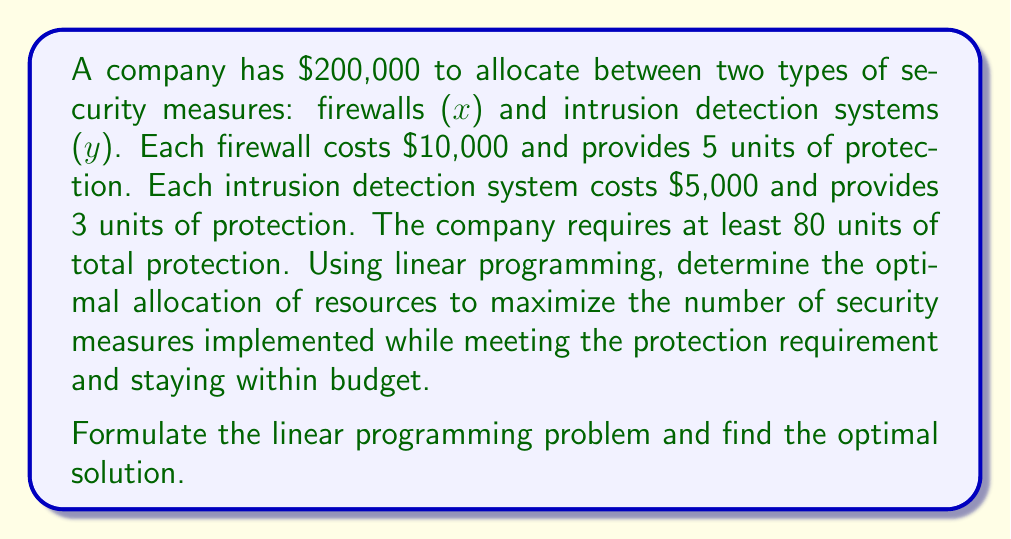What is the answer to this math problem? Let's approach this step-by-step:

1. Define variables:
   x = number of firewalls
   y = number of intrusion detection systems

2. Objective function:
   Maximize Z = x + y (total number of security measures)

3. Constraints:
   a. Budget constraint: $10,000x + $5,000y ≤ $200,000
   b. Protection requirement: 5x + 3y ≥ 80
   c. Non-negativity: x ≥ 0, y ≥ 0

4. Simplify the constraints:
   a. 2x + y ≤ 40
   b. 5x + 3y ≥ 80

5. Graph the constraints:
   [asy]
   import graph;
   size(200);
   xaxis("x", 0, 25);
   yaxis("y", 0, 45);
   draw((0,40)--(20,0), blue);
   draw((0,80/3)--(16,0), red);
   fill((0,80/3)--(16,0)--(20,0)--(0,40)--cycle, palegreen);
   label("Feasible Region", (10,20), green);
   dot((10,20));
   label("(10, 20)", (10,22), N);
   [/asy]

6. Identify corner points of the feasible region:
   (0, 40), (16, 0), and the intersection point (10, 20)

7. Evaluate the objective function at these points:
   (0, 40): Z = 0 + 40 = 40
   (16, 0): Z = 16 + 0 = 16
   (10, 20): Z = 10 + 20 = 30

8. The maximum value of Z occurs at (10, 20), which represents 10 firewalls and 20 intrusion detection systems.

9. Verify the solution:
   Budget: 10(10,000) + 20(5,000) = 100,000 + 100,000 = 200,000
   Protection: 10(5) + 20(3) = 50 + 60 = 110 units

The optimal solution satisfies all constraints and maximizes the number of security measures.
Answer: 10 firewalls, 20 intrusion detection systems 